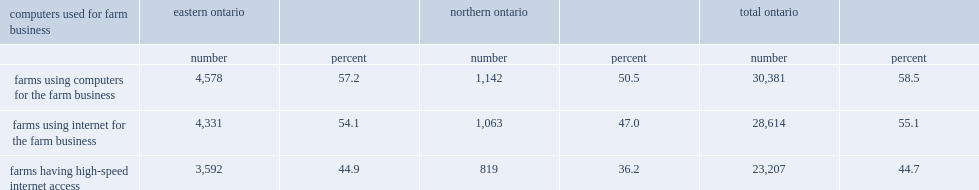In 2011, which region has the lowest proportion of farm operators that used computers or the internet for farm operations? Northern ontario. 